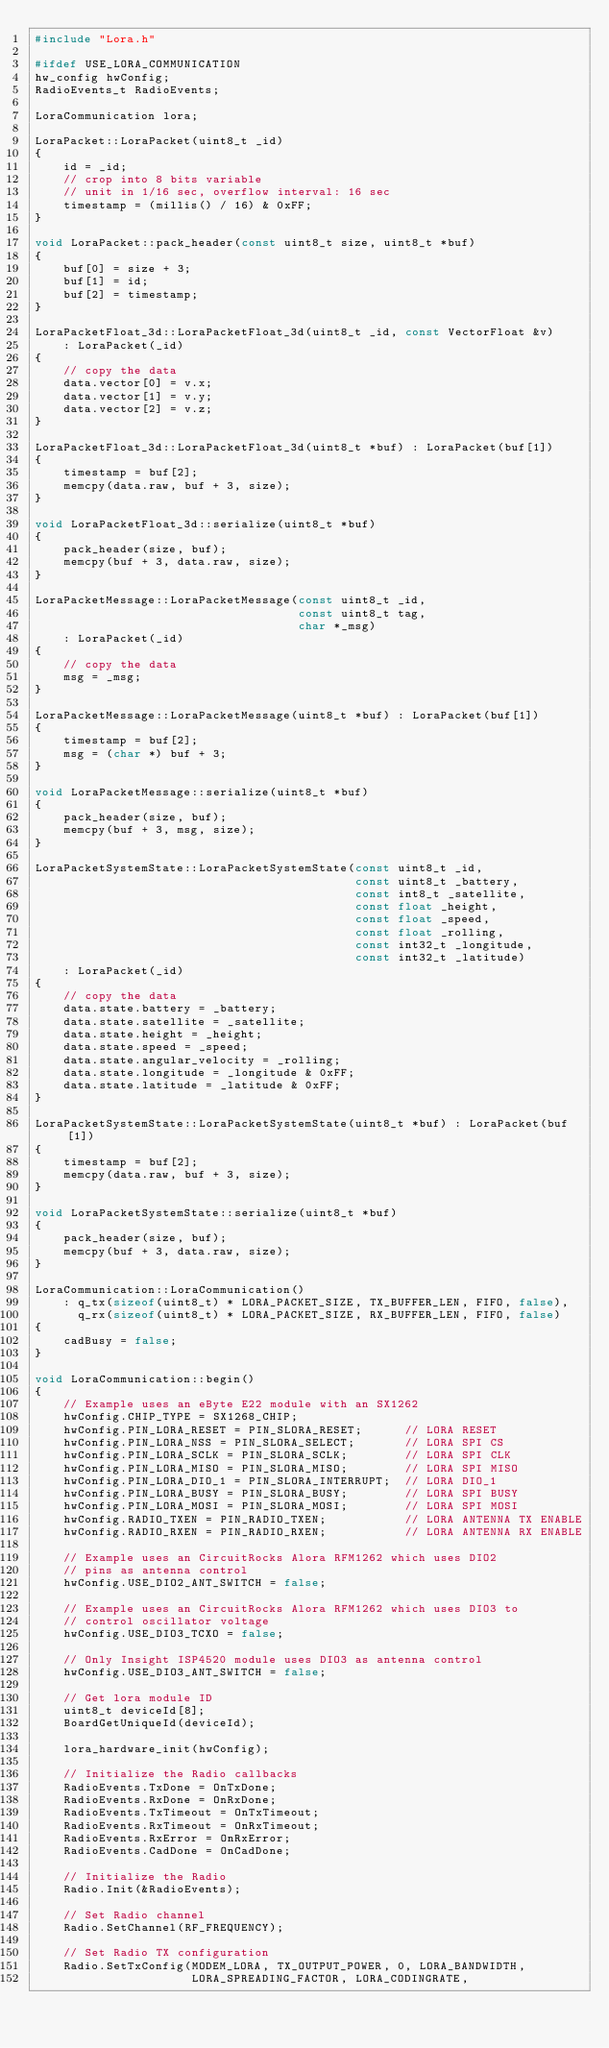<code> <loc_0><loc_0><loc_500><loc_500><_C++_>#include "Lora.h"

#ifdef USE_LORA_COMMUNICATION
hw_config hwConfig;
RadioEvents_t RadioEvents;

LoraCommunication lora;

LoraPacket::LoraPacket(uint8_t _id)
{
    id = _id;
    // crop into 8 bits variable
    // unit in 1/16 sec, overflow interval: 16 sec
    timestamp = (millis() / 16) & 0xFF;
}

void LoraPacket::pack_header(const uint8_t size, uint8_t *buf)
{
    buf[0] = size + 3;
    buf[1] = id;
    buf[2] = timestamp;
}

LoraPacketFloat_3d::LoraPacketFloat_3d(uint8_t _id, const VectorFloat &v)
    : LoraPacket(_id)
{
    // copy the data
    data.vector[0] = v.x;
    data.vector[1] = v.y;
    data.vector[2] = v.z;
}

LoraPacketFloat_3d::LoraPacketFloat_3d(uint8_t *buf) : LoraPacket(buf[1])
{
    timestamp = buf[2];
    memcpy(data.raw, buf + 3, size);
}

void LoraPacketFloat_3d::serialize(uint8_t *buf)
{
    pack_header(size, buf);
    memcpy(buf + 3, data.raw, size);
}

LoraPacketMessage::LoraPacketMessage(const uint8_t _id,
                                     const uint8_t tag,
                                     char *_msg)
    : LoraPacket(_id)
{
    // copy the data
    msg = _msg;
}

LoraPacketMessage::LoraPacketMessage(uint8_t *buf) : LoraPacket(buf[1])
{
    timestamp = buf[2];
    msg = (char *) buf + 3;
}

void LoraPacketMessage::serialize(uint8_t *buf)
{
    pack_header(size, buf);
    memcpy(buf + 3, msg, size);
}

LoraPacketSystemState::LoraPacketSystemState(const uint8_t _id,
                                             const uint8_t _battery,
                                             const int8_t _satellite,
                                             const float _height,
                                             const float _speed,
                                             const float _rolling,
                                             const int32_t _longitude,
                                             const int32_t _latitude)
    : LoraPacket(_id)
{
    // copy the data
    data.state.battery = _battery;
    data.state.satellite = _satellite;
    data.state.height = _height;
    data.state.speed = _speed;
    data.state.angular_velocity = _rolling;
    data.state.longitude = _longitude & 0xFF;
    data.state.latitude = _latitude & 0xFF;
}

LoraPacketSystemState::LoraPacketSystemState(uint8_t *buf) : LoraPacket(buf[1])
{
    timestamp = buf[2];
    memcpy(data.raw, buf + 3, size);
}

void LoraPacketSystemState::serialize(uint8_t *buf)
{
    pack_header(size, buf);
    memcpy(buf + 3, data.raw, size);
}

LoraCommunication::LoraCommunication()
    : q_tx(sizeof(uint8_t) * LORA_PACKET_SIZE, TX_BUFFER_LEN, FIFO, false),
      q_rx(sizeof(uint8_t) * LORA_PACKET_SIZE, RX_BUFFER_LEN, FIFO, false)
{
    cadBusy = false;
}

void LoraCommunication::begin()
{
    // Example uses an eByte E22 module with an SX1262
    hwConfig.CHIP_TYPE = SX1268_CHIP;
    hwConfig.PIN_LORA_RESET = PIN_SLORA_RESET;      // LORA RESET
    hwConfig.PIN_LORA_NSS = PIN_SLORA_SELECT;       // LORA SPI CS
    hwConfig.PIN_LORA_SCLK = PIN_SLORA_SCLK;        // LORA SPI CLK
    hwConfig.PIN_LORA_MISO = PIN_SLORA_MISO;        // LORA SPI MISO
    hwConfig.PIN_LORA_DIO_1 = PIN_SLORA_INTERRUPT;  // LORA DIO_1
    hwConfig.PIN_LORA_BUSY = PIN_SLORA_BUSY;        // LORA SPI BUSY
    hwConfig.PIN_LORA_MOSI = PIN_SLORA_MOSI;        // LORA SPI MOSI
    hwConfig.RADIO_TXEN = PIN_RADIO_TXEN;           // LORA ANTENNA TX ENABLE
    hwConfig.RADIO_RXEN = PIN_RADIO_RXEN;           // LORA ANTENNA RX ENABLE

    // Example uses an CircuitRocks Alora RFM1262 which uses DIO2
    // pins as antenna control
    hwConfig.USE_DIO2_ANT_SWITCH = false;

    // Example uses an CircuitRocks Alora RFM1262 which uses DIO3 to
    // control oscillator voltage
    hwConfig.USE_DIO3_TCXO = false;

    // Only Insight ISP4520 module uses DIO3 as antenna control
    hwConfig.USE_DIO3_ANT_SWITCH = false;

    // Get lora module ID
    uint8_t deviceId[8];
    BoardGetUniqueId(deviceId);

    lora_hardware_init(hwConfig);

    // Initialize the Radio callbacks
    RadioEvents.TxDone = OnTxDone;
    RadioEvents.RxDone = OnRxDone;
    RadioEvents.TxTimeout = OnTxTimeout;
    RadioEvents.RxTimeout = OnRxTimeout;
    RadioEvents.RxError = OnRxError;
    RadioEvents.CadDone = OnCadDone;

    // Initialize the Radio
    Radio.Init(&RadioEvents);

    // Set Radio channel
    Radio.SetChannel(RF_FREQUENCY);

    // Set Radio TX configuration
    Radio.SetTxConfig(MODEM_LORA, TX_OUTPUT_POWER, 0, LORA_BANDWIDTH,
                      LORA_SPREADING_FACTOR, LORA_CODINGRATE,</code> 